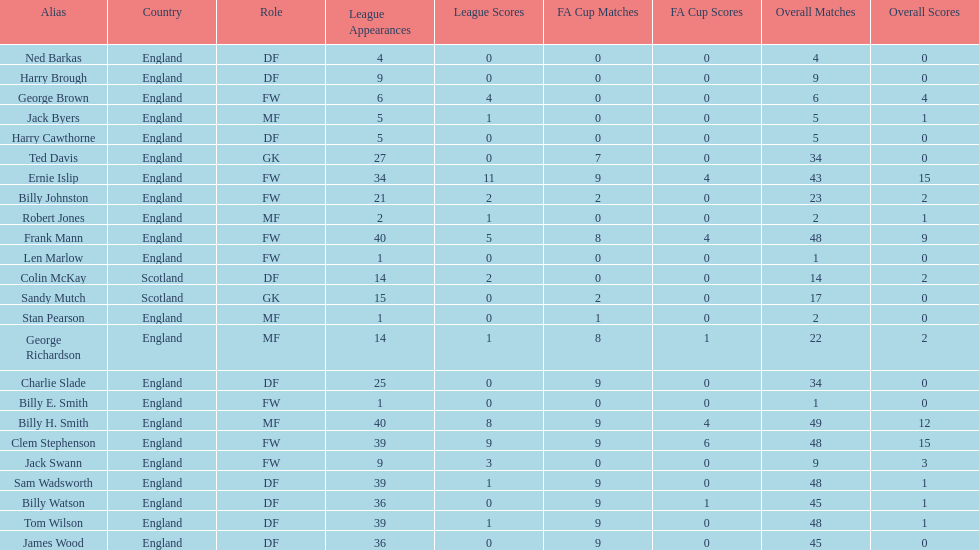What is the last name listed on this chart? James Wood. 